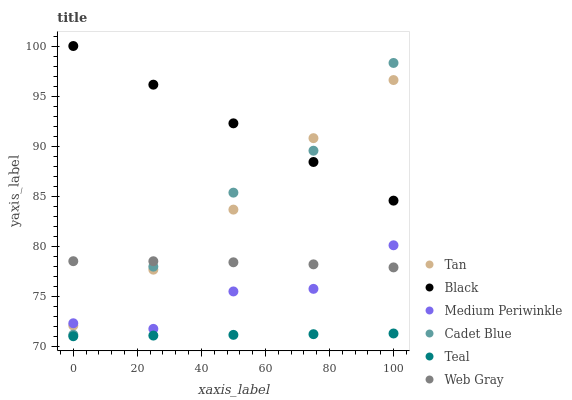Does Teal have the minimum area under the curve?
Answer yes or no. Yes. Does Black have the maximum area under the curve?
Answer yes or no. Yes. Does Medium Periwinkle have the minimum area under the curve?
Answer yes or no. No. Does Medium Periwinkle have the maximum area under the curve?
Answer yes or no. No. Is Black the smoothest?
Answer yes or no. Yes. Is Medium Periwinkle the roughest?
Answer yes or no. Yes. Is Cadet Blue the smoothest?
Answer yes or no. No. Is Cadet Blue the roughest?
Answer yes or no. No. Does Teal have the lowest value?
Answer yes or no. Yes. Does Medium Periwinkle have the lowest value?
Answer yes or no. No. Does Black have the highest value?
Answer yes or no. Yes. Does Medium Periwinkle have the highest value?
Answer yes or no. No. Is Teal less than Tan?
Answer yes or no. Yes. Is Tan greater than Teal?
Answer yes or no. Yes. Does Black intersect Cadet Blue?
Answer yes or no. Yes. Is Black less than Cadet Blue?
Answer yes or no. No. Is Black greater than Cadet Blue?
Answer yes or no. No. Does Teal intersect Tan?
Answer yes or no. No. 